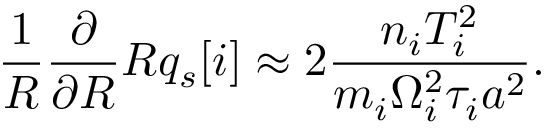<formula> <loc_0><loc_0><loc_500><loc_500>\frac { 1 } { R } { \frac { \partial } { \partial R } } R q _ { s } [ i ] \approx 2 \frac { n _ { i } T _ { i } ^ { 2 } } { m _ { i } \Omega _ { i } ^ { 2 } \tau _ { i } a ^ { 2 } } .</formula> 